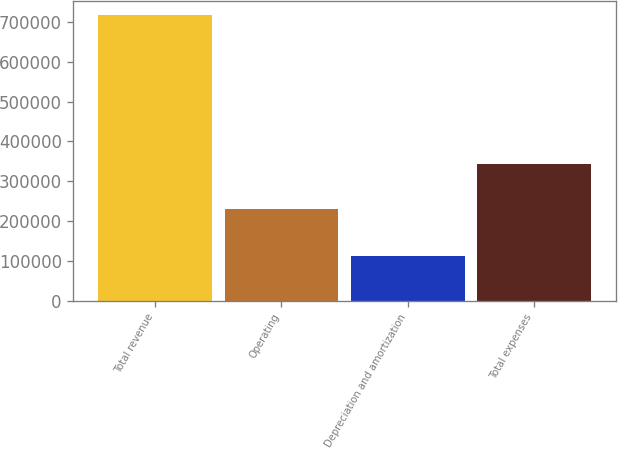Convert chart. <chart><loc_0><loc_0><loc_500><loc_500><bar_chart><fcel>Total revenue<fcel>Operating<fcel>Depreciation and amortization<fcel>Total expenses<nl><fcel>717654<fcel>230178<fcel>112463<fcel>342641<nl></chart> 